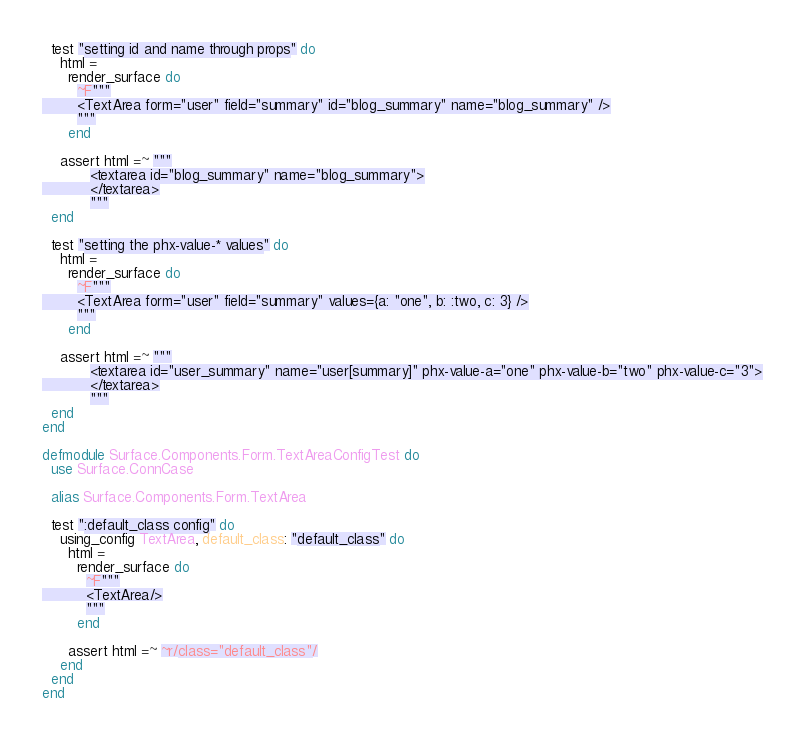Convert code to text. <code><loc_0><loc_0><loc_500><loc_500><_Elixir_>  test "setting id and name through props" do
    html =
      render_surface do
        ~F"""
        <TextArea form="user" field="summary" id="blog_summary" name="blog_summary" />
        """
      end

    assert html =~ """
           <textarea id="blog_summary" name="blog_summary">
           </textarea>
           """
  end

  test "setting the phx-value-* values" do
    html =
      render_surface do
        ~F"""
        <TextArea form="user" field="summary" values={a: "one", b: :two, c: 3} />
        """
      end

    assert html =~ """
           <textarea id="user_summary" name="user[summary]" phx-value-a="one" phx-value-b="two" phx-value-c="3">
           </textarea>
           """
  end
end

defmodule Surface.Components.Form.TextAreaConfigTest do
  use Surface.ConnCase

  alias Surface.Components.Form.TextArea

  test ":default_class config" do
    using_config TextArea, default_class: "default_class" do
      html =
        render_surface do
          ~F"""
          <TextArea/>
          """
        end

      assert html =~ ~r/class="default_class"/
    end
  end
end
</code> 